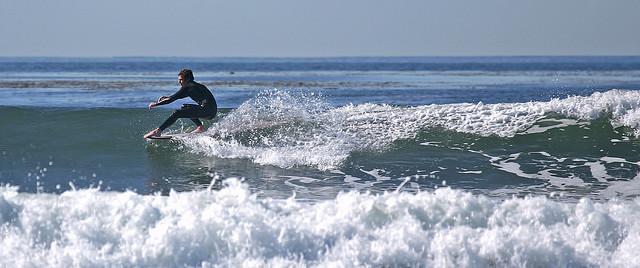How many blue box by the red couch and located on the left of the coffee table ?
Give a very brief answer. 0. 